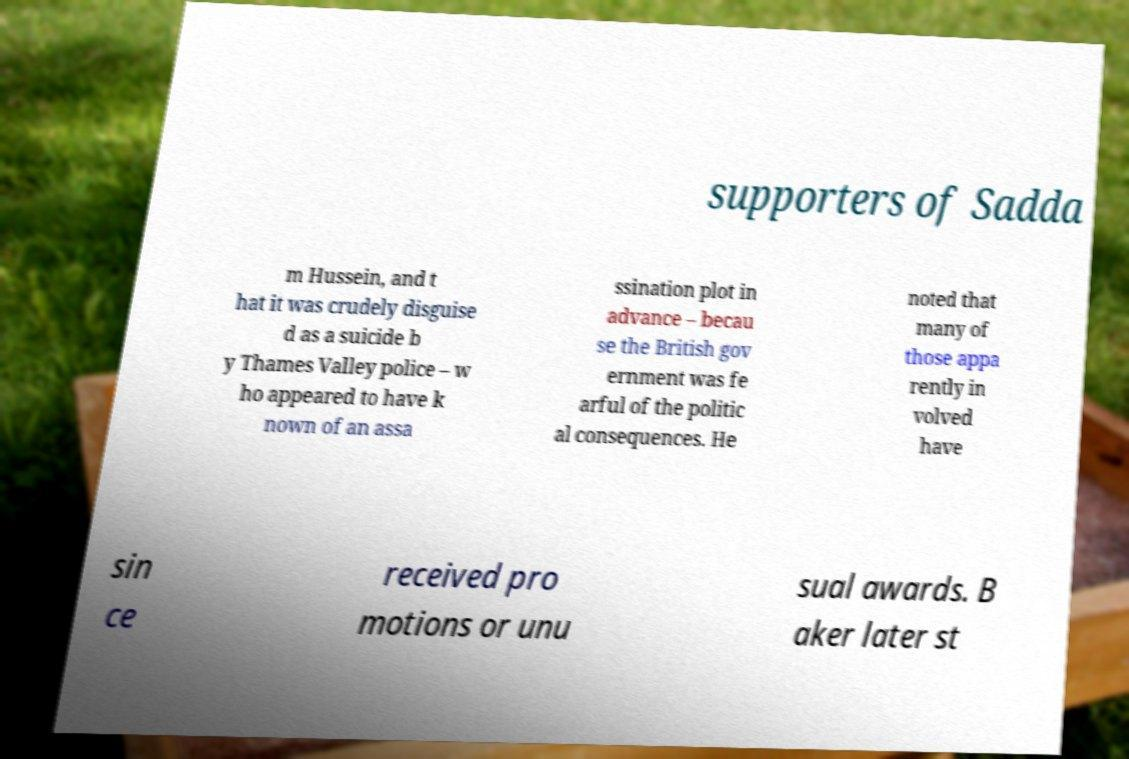Please identify and transcribe the text found in this image. supporters of Sadda m Hussein, and t hat it was crudely disguise d as a suicide b y Thames Valley police – w ho appeared to have k nown of an assa ssination plot in advance – becau se the British gov ernment was fe arful of the politic al consequences. He noted that many of those appa rently in volved have sin ce received pro motions or unu sual awards. B aker later st 